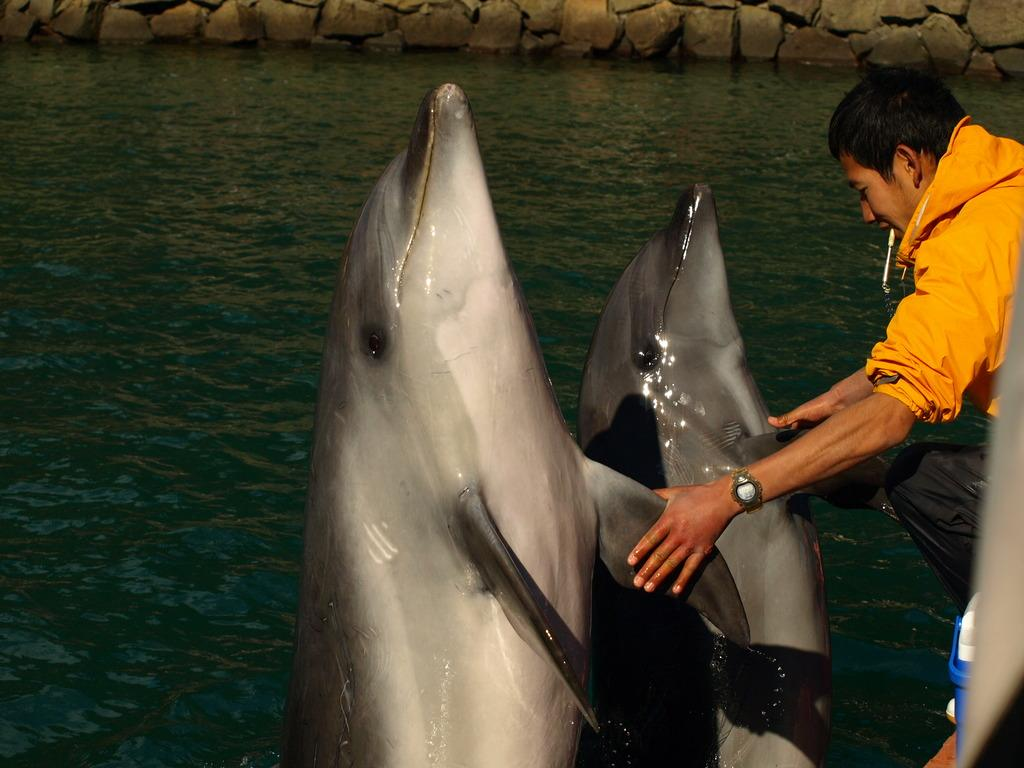Who or what is present in the image? There is a person in the image. What is the person holding in the image? The person is holding dolphins. What can be seen in the background of the image? There is water visible in the image. What type of growth can be seen on the lamp in the image? There is no lamp present in the image, so it is not possible to determine if there is any growth on it. 